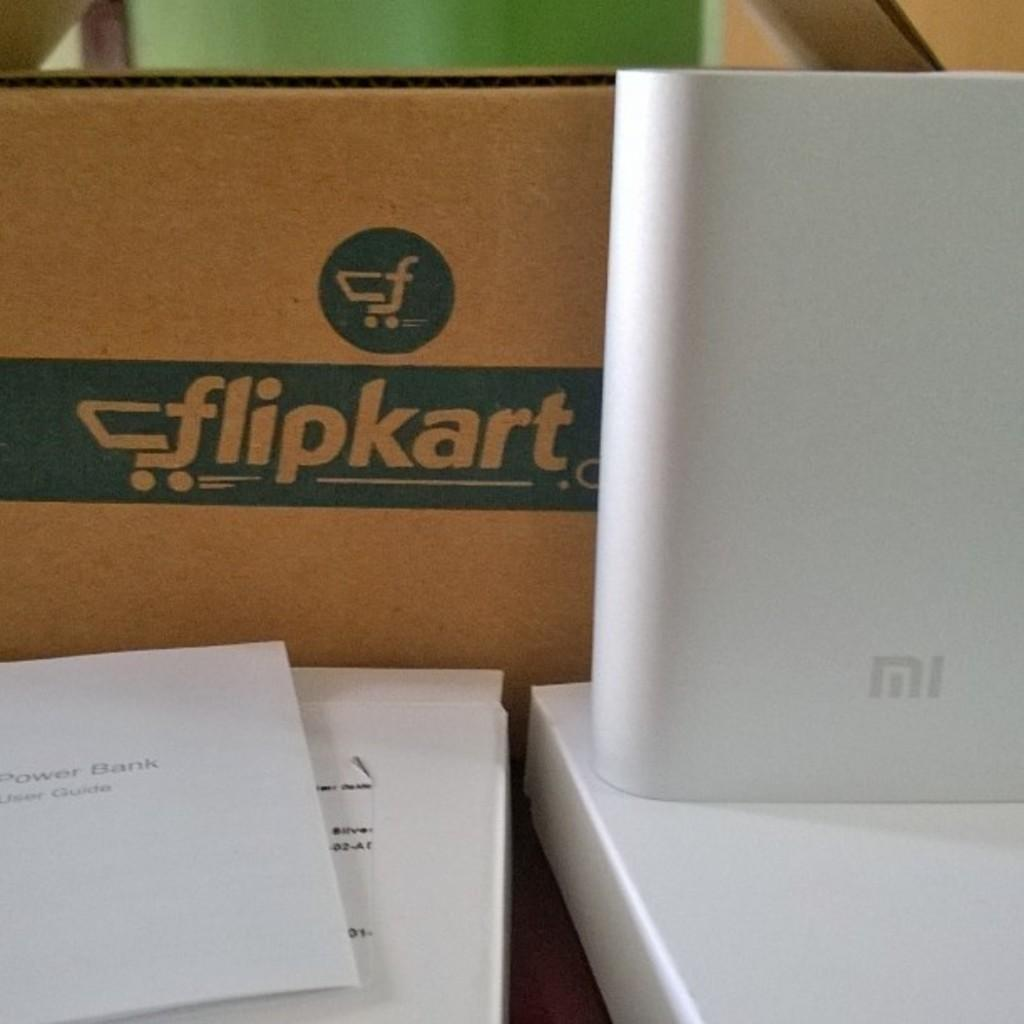<image>
Share a concise interpretation of the image provided. a box sitting behind a table with a flipkart.com logo on it 